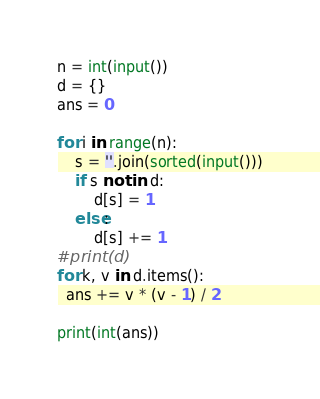Convert code to text. <code><loc_0><loc_0><loc_500><loc_500><_Python_>n = int(input())
d = {}
ans = 0

for i in range(n):
    s = ''.join(sorted(input()))
    if s not in d:
        d[s] = 1
    else:
        d[s] += 1
#print(d)
for k, v in d.items():
  ans += v * (v - 1) / 2

print(int(ans))

</code> 